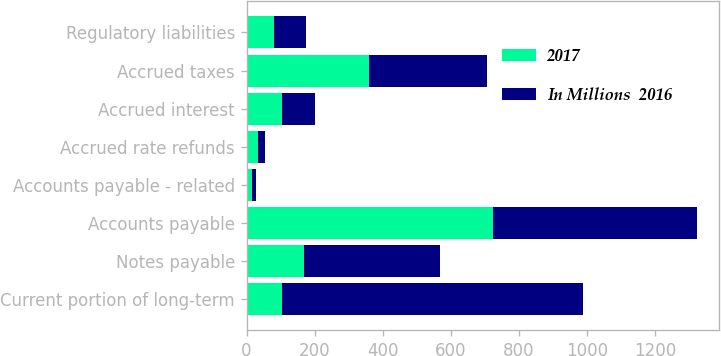Convert chart to OTSL. <chart><loc_0><loc_0><loc_500><loc_500><stacked_bar_chart><ecel><fcel>Current portion of long-term<fcel>Notes payable<fcel>Accounts payable<fcel>Accounts payable - related<fcel>Accrued rate refunds<fcel>Accrued interest<fcel>Accrued taxes<fcel>Regulatory liabilities<nl><fcel>2017<fcel>103<fcel>170<fcel>725<fcel>15<fcel>33<fcel>103<fcel>360<fcel>80<nl><fcel>In Millions  2016<fcel>886<fcel>398<fcel>598<fcel>12<fcel>21<fcel>98<fcel>348<fcel>95<nl></chart> 